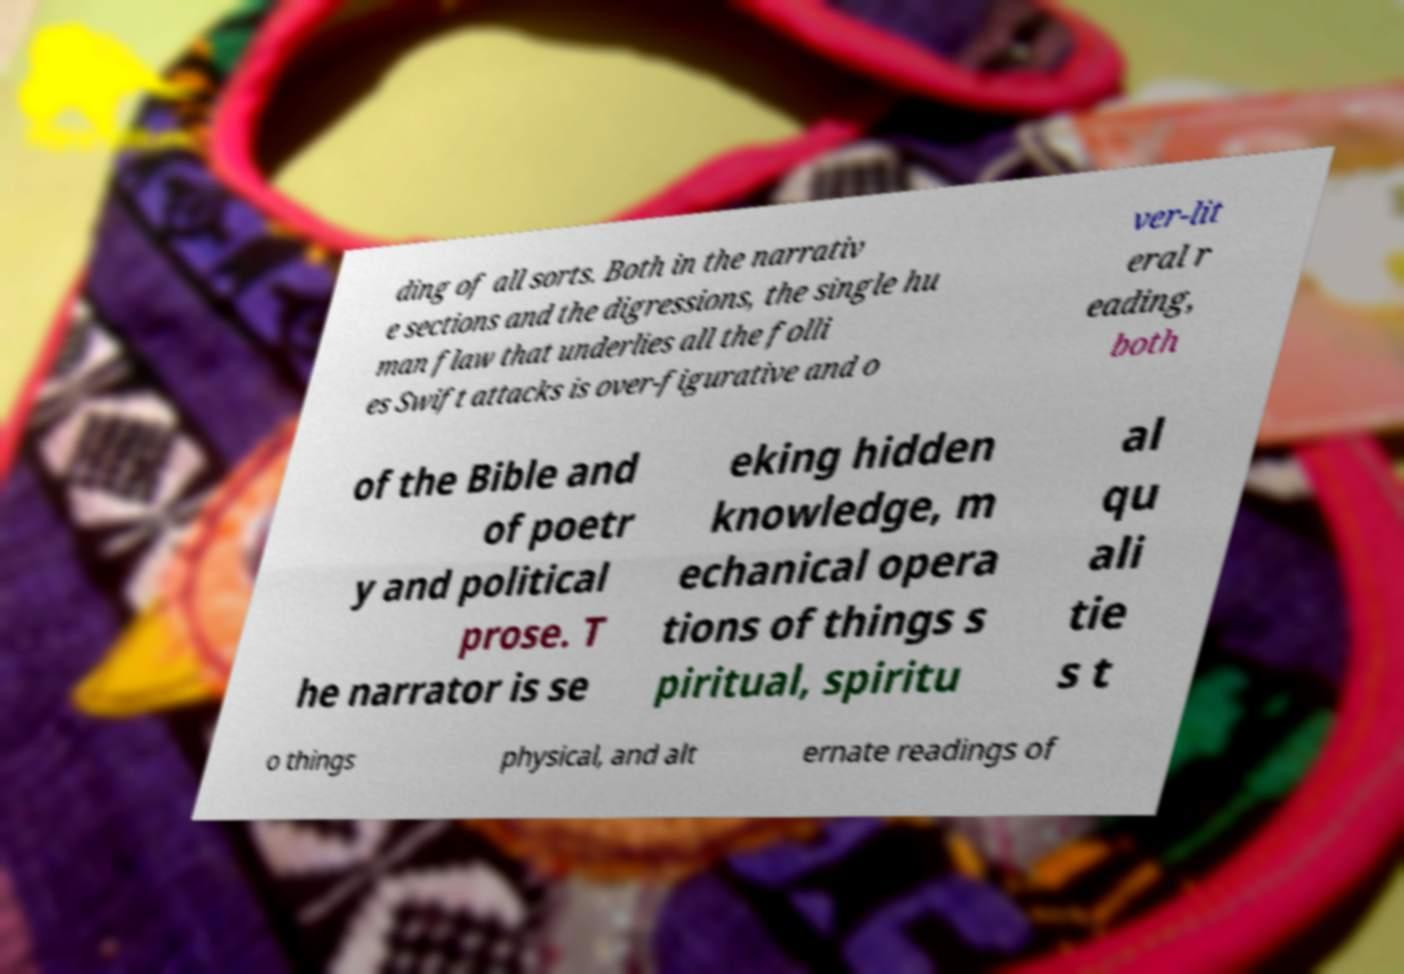I need the written content from this picture converted into text. Can you do that? ding of all sorts. Both in the narrativ e sections and the digressions, the single hu man flaw that underlies all the folli es Swift attacks is over-figurative and o ver-lit eral r eading, both of the Bible and of poetr y and political prose. T he narrator is se eking hidden knowledge, m echanical opera tions of things s piritual, spiritu al qu ali tie s t o things physical, and alt ernate readings of 